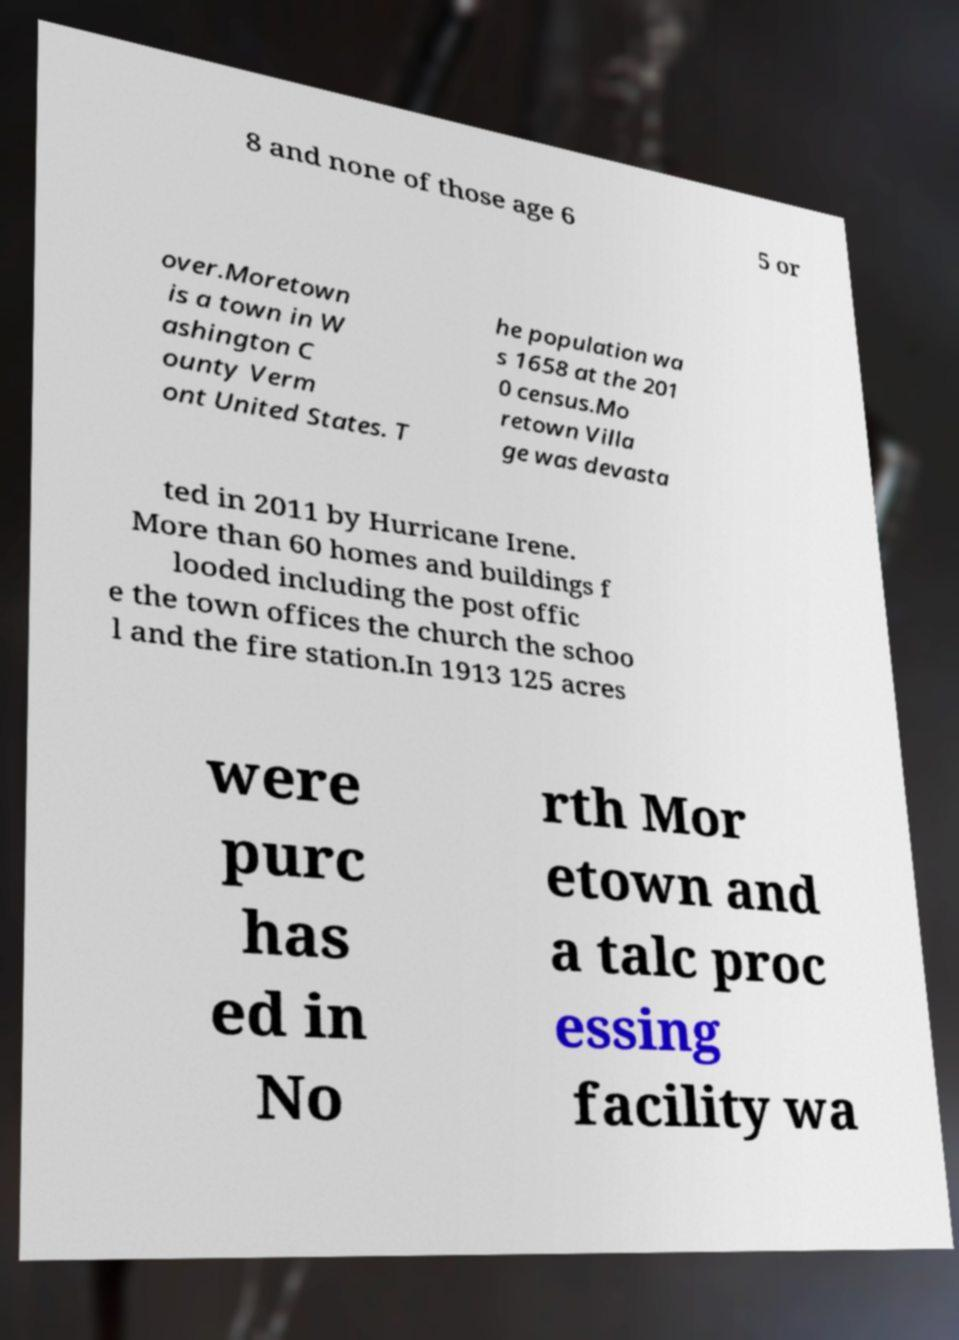Can you read and provide the text displayed in the image?This photo seems to have some interesting text. Can you extract and type it out for me? 8 and none of those age 6 5 or over.Moretown is a town in W ashington C ounty Verm ont United States. T he population wa s 1658 at the 201 0 census.Mo retown Villa ge was devasta ted in 2011 by Hurricane Irene. More than 60 homes and buildings f looded including the post offic e the town offices the church the schoo l and the fire station.In 1913 125 acres were purc has ed in No rth Mor etown and a talc proc essing facility wa 